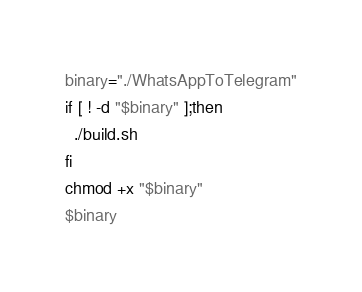<code> <loc_0><loc_0><loc_500><loc_500><_Bash_>binary="./WhatsAppToTelegram"
if [ ! -d "$binary" ];then
  ./build.sh
fi
chmod +x "$binary"
$binary</code> 